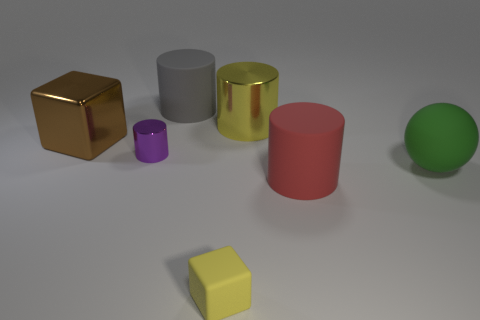There is a gray object that is the same shape as the small purple metallic object; what is its material?
Provide a succinct answer. Rubber. There is a tiny matte object that is the same color as the large shiny cylinder; what shape is it?
Give a very brief answer. Cube. Does the rubber cylinder that is to the right of the large yellow shiny cylinder have the same color as the metallic cylinder that is in front of the big block?
Your response must be concise. No. How many large cylinders are both in front of the large green rubber thing and behind the brown cube?
Your response must be concise. 0. What material is the tiny cylinder?
Keep it short and to the point. Metal. What is the shape of the purple object that is the same size as the rubber cube?
Provide a succinct answer. Cylinder. Are the cylinder to the right of the yellow cylinder and the yellow thing in front of the yellow metal cylinder made of the same material?
Provide a succinct answer. Yes. How many large gray matte cylinders are there?
Provide a short and direct response. 1. How many red objects have the same shape as the large green thing?
Keep it short and to the point. 0. Is the tiny metallic thing the same shape as the big green object?
Provide a short and direct response. No. 